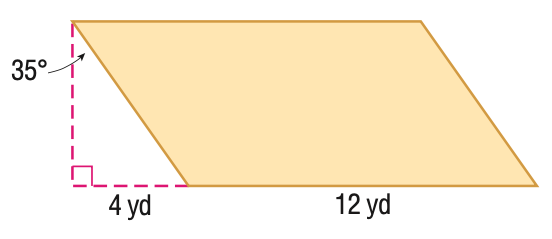Question: Find the perimeter of the figure. Round to the nearest hundredth, if necessary.
Choices:
A. 32
B. 33.8
C. 35.4
D. 37.9
Answer with the letter. Answer: D Question: Find the area of the figure. Round to the nearest hundredth, if necessary.
Choices:
A. 33.6
B. 48
C. 58.6
D. 68.6
Answer with the letter. Answer: D 